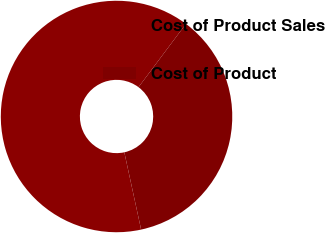Convert chart to OTSL. <chart><loc_0><loc_0><loc_500><loc_500><pie_chart><fcel>Cost of Product Sales<fcel>Cost of Product<nl><fcel>63.64%<fcel>36.36%<nl></chart> 